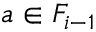<formula> <loc_0><loc_0><loc_500><loc_500>a \in F _ { i - 1 }</formula> 